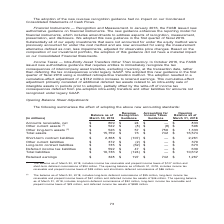According to Nortonlifelock's financial document, What does the table show? summarizes the effect of adopting the above new accounting standards. The document states: "The following summarizes the effect of adopting the above new accounting standards:..." Also, What is the Opening balance as of March 31, 2018 for Accounts receivable, net? According to the financial document, $809 (in millions). The relevant text states: "Accounts receivable, net $ 809 $ 24 $ — $ 833 Other current assets (1) $ 522 $ (8) $ (8) $ 506 Other long-term assets (2) $ 526 $..." Also, What is the Opening balance as of March 31, 2018 for Total assets? According to the financial document, $16,574 (in millions). The relevant text states: "$ 750 $ 1,333 Total assets $ 15,759 $ 73 $ 742 $ 16,574..." Also, can you calculate: What is the percentage increase in Accounts receivable, net from Balance as of March 30, 2018 to Opening balance as of March 31, 2018? Based on the calculation: 24/809, the result is 2.97 (percentage). This is based on the information: "Accounts receivable, net $ 809 $ 24 $ — $ 833 Other current assets (1) $ 522 $ (8) $ (8) $ 506 Other long-term assets (2) $ 526 $ 57 $ Accounts receivable, net $ 809 $ 24 $ — $ 833 Other current asset..." The key data points involved are: 24, 809. Also, can you calculate: What is the percentage increase in Total assets from Balance as of March 30, 2018 to Opening balance as of March 31, 2018? To answer this question, I need to perform calculations using the financial data. The calculation is: (73+742)/15,759, which equals 5.17 (percentage). This is based on the information: "ssets (2) $ 526 $ 57 $ 750 $ 1,333 Total assets $ 15,759 $ 73 $ 742 $ 16,574 resulted in a cumulative-effect adjustment of a $742 million increase to retained earnings. This cumulative-effect adjustme..." The key data points involved are: 15,759, 73, 742. Also, can you calculate: What is the percentage change in Total liabilities from Balance as of March 30, 2018 to Opening balance as of March 31, 2018? To answer this question, I need to perform calculations using the financial data. The calculation is: -124/10,736, which equals -1.15 (percentage). This is based on the information: "592 $ 47 $ — $ 639 Total liabilities $ 10,736 $ (124) $ — $ 10,612 bilities $ 592 $ 47 $ — $ 639 Total liabilities $ 10,736 $ (124) $ — $ 10,612..." The key data points involved are: 10,736, 124. 